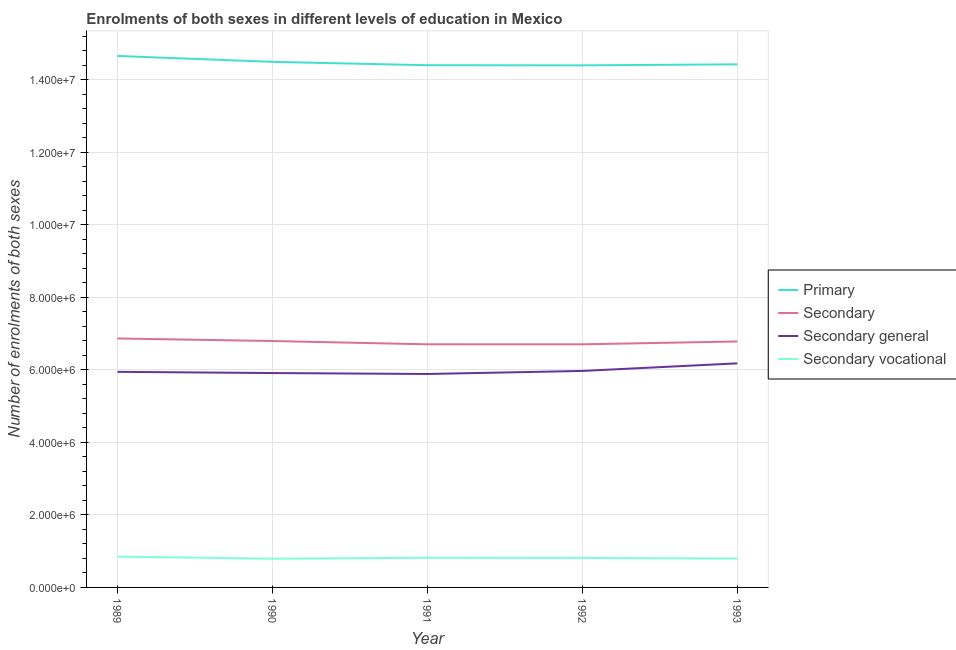How many different coloured lines are there?
Provide a succinct answer. 4. Does the line corresponding to number of enrolments in secondary vocational education intersect with the line corresponding to number of enrolments in secondary general education?
Provide a succinct answer. No. Is the number of lines equal to the number of legend labels?
Your answer should be compact. Yes. What is the number of enrolments in secondary vocational education in 1992?
Provide a short and direct response. 8.13e+05. Across all years, what is the maximum number of enrolments in primary education?
Provide a short and direct response. 1.47e+07. Across all years, what is the minimum number of enrolments in primary education?
Your response must be concise. 1.44e+07. In which year was the number of enrolments in secondary general education maximum?
Keep it short and to the point. 1993. In which year was the number of enrolments in primary education minimum?
Your answer should be very brief. 1992. What is the total number of enrolments in secondary education in the graph?
Your answer should be compact. 3.39e+07. What is the difference between the number of enrolments in secondary general education in 1990 and that in 1991?
Ensure brevity in your answer.  2.58e+04. What is the difference between the number of enrolments in secondary education in 1989 and the number of enrolments in secondary vocational education in 1991?
Ensure brevity in your answer.  6.05e+06. What is the average number of enrolments in primary education per year?
Your response must be concise. 1.45e+07. In the year 1993, what is the difference between the number of enrolments in secondary education and number of enrolments in secondary general education?
Provide a short and direct response. 6.03e+05. In how many years, is the number of enrolments in secondary general education greater than 4800000?
Provide a succinct answer. 5. What is the ratio of the number of enrolments in primary education in 1989 to that in 1992?
Give a very brief answer. 1.02. Is the number of enrolments in secondary education in 1989 less than that in 1990?
Your answer should be very brief. No. What is the difference between the highest and the second highest number of enrolments in secondary general education?
Offer a terse response. 2.09e+05. What is the difference between the highest and the lowest number of enrolments in secondary education?
Make the answer very short. 1.62e+05. Is the sum of the number of enrolments in secondary education in 1990 and 1993 greater than the maximum number of enrolments in secondary vocational education across all years?
Your response must be concise. Yes. Is it the case that in every year, the sum of the number of enrolments in primary education and number of enrolments in secondary education is greater than the number of enrolments in secondary general education?
Ensure brevity in your answer.  Yes. Is the number of enrolments in secondary education strictly less than the number of enrolments in secondary general education over the years?
Offer a very short reply. No. How many lines are there?
Your answer should be compact. 4. Does the graph contain grids?
Your answer should be very brief. Yes. What is the title of the graph?
Offer a very short reply. Enrolments of both sexes in different levels of education in Mexico. What is the label or title of the X-axis?
Ensure brevity in your answer.  Year. What is the label or title of the Y-axis?
Keep it short and to the point. Number of enrolments of both sexes. What is the Number of enrolments of both sexes of Primary in 1989?
Offer a very short reply. 1.47e+07. What is the Number of enrolments of both sexes of Secondary in 1989?
Ensure brevity in your answer.  6.87e+06. What is the Number of enrolments of both sexes in Secondary general in 1989?
Make the answer very short. 5.95e+06. What is the Number of enrolments of both sexes in Secondary vocational in 1989?
Your answer should be very brief. 8.50e+05. What is the Number of enrolments of both sexes of Primary in 1990?
Provide a short and direct response. 1.45e+07. What is the Number of enrolments of both sexes in Secondary in 1990?
Your answer should be compact. 6.80e+06. What is the Number of enrolments of both sexes in Secondary general in 1990?
Ensure brevity in your answer.  5.91e+06. What is the Number of enrolments of both sexes of Secondary vocational in 1990?
Keep it short and to the point. 7.92e+05. What is the Number of enrolments of both sexes in Primary in 1991?
Make the answer very short. 1.44e+07. What is the Number of enrolments of both sexes of Secondary in 1991?
Make the answer very short. 6.70e+06. What is the Number of enrolments of both sexes of Secondary general in 1991?
Your response must be concise. 5.89e+06. What is the Number of enrolments of both sexes in Secondary vocational in 1991?
Offer a terse response. 8.18e+05. What is the Number of enrolments of both sexes of Primary in 1992?
Ensure brevity in your answer.  1.44e+07. What is the Number of enrolments of both sexes in Secondary in 1992?
Offer a terse response. 6.70e+06. What is the Number of enrolments of both sexes in Secondary general in 1992?
Keep it short and to the point. 5.97e+06. What is the Number of enrolments of both sexes in Secondary vocational in 1992?
Provide a succinct answer. 8.13e+05. What is the Number of enrolments of both sexes in Primary in 1993?
Make the answer very short. 1.44e+07. What is the Number of enrolments of both sexes of Secondary in 1993?
Make the answer very short. 6.78e+06. What is the Number of enrolments of both sexes of Secondary general in 1993?
Offer a very short reply. 6.18e+06. What is the Number of enrolments of both sexes of Secondary vocational in 1993?
Your answer should be very brief. 7.98e+05. Across all years, what is the maximum Number of enrolments of both sexes in Primary?
Keep it short and to the point. 1.47e+07. Across all years, what is the maximum Number of enrolments of both sexes of Secondary?
Keep it short and to the point. 6.87e+06. Across all years, what is the maximum Number of enrolments of both sexes of Secondary general?
Make the answer very short. 6.18e+06. Across all years, what is the maximum Number of enrolments of both sexes of Secondary vocational?
Offer a terse response. 8.50e+05. Across all years, what is the minimum Number of enrolments of both sexes in Primary?
Provide a succinct answer. 1.44e+07. Across all years, what is the minimum Number of enrolments of both sexes of Secondary?
Your answer should be compact. 6.70e+06. Across all years, what is the minimum Number of enrolments of both sexes of Secondary general?
Provide a succinct answer. 5.89e+06. Across all years, what is the minimum Number of enrolments of both sexes in Secondary vocational?
Make the answer very short. 7.92e+05. What is the total Number of enrolments of both sexes of Primary in the graph?
Offer a very short reply. 7.24e+07. What is the total Number of enrolments of both sexes in Secondary in the graph?
Offer a terse response. 3.39e+07. What is the total Number of enrolments of both sexes in Secondary general in the graph?
Ensure brevity in your answer.  2.99e+07. What is the total Number of enrolments of both sexes of Secondary vocational in the graph?
Keep it short and to the point. 4.07e+06. What is the difference between the Number of enrolments of both sexes in Primary in 1989 and that in 1990?
Offer a very short reply. 1.63e+05. What is the difference between the Number of enrolments of both sexes in Secondary in 1989 and that in 1990?
Your response must be concise. 7.05e+04. What is the difference between the Number of enrolments of both sexes of Secondary general in 1989 and that in 1990?
Ensure brevity in your answer.  3.38e+04. What is the difference between the Number of enrolments of both sexes in Secondary vocational in 1989 and that in 1990?
Your answer should be compact. 5.72e+04. What is the difference between the Number of enrolments of both sexes of Primary in 1989 and that in 1991?
Provide a short and direct response. 2.55e+05. What is the difference between the Number of enrolments of both sexes in Secondary in 1989 and that in 1991?
Ensure brevity in your answer.  1.61e+05. What is the difference between the Number of enrolments of both sexes in Secondary general in 1989 and that in 1991?
Make the answer very short. 5.96e+04. What is the difference between the Number of enrolments of both sexes in Secondary vocational in 1989 and that in 1991?
Provide a short and direct response. 3.14e+04. What is the difference between the Number of enrolments of both sexes in Primary in 1989 and that in 1992?
Offer a very short reply. 2.59e+05. What is the difference between the Number of enrolments of both sexes of Secondary in 1989 and that in 1992?
Keep it short and to the point. 1.62e+05. What is the difference between the Number of enrolments of both sexes in Secondary general in 1989 and that in 1992?
Provide a succinct answer. -2.45e+04. What is the difference between the Number of enrolments of both sexes of Secondary vocational in 1989 and that in 1992?
Keep it short and to the point. 3.69e+04. What is the difference between the Number of enrolments of both sexes of Primary in 1989 and that in 1993?
Make the answer very short. 2.31e+05. What is the difference between the Number of enrolments of both sexes of Secondary in 1989 and that in 1993?
Make the answer very short. 8.29e+04. What is the difference between the Number of enrolments of both sexes in Secondary general in 1989 and that in 1993?
Offer a terse response. -2.34e+05. What is the difference between the Number of enrolments of both sexes in Secondary vocational in 1989 and that in 1993?
Offer a very short reply. 5.21e+04. What is the difference between the Number of enrolments of both sexes in Primary in 1990 and that in 1991?
Your answer should be very brief. 9.22e+04. What is the difference between the Number of enrolments of both sexes in Secondary in 1990 and that in 1991?
Your answer should be compact. 9.09e+04. What is the difference between the Number of enrolments of both sexes of Secondary general in 1990 and that in 1991?
Ensure brevity in your answer.  2.58e+04. What is the difference between the Number of enrolments of both sexes in Secondary vocational in 1990 and that in 1991?
Provide a succinct answer. -2.57e+04. What is the difference between the Number of enrolments of both sexes in Primary in 1990 and that in 1992?
Your answer should be very brief. 9.68e+04. What is the difference between the Number of enrolments of both sexes of Secondary in 1990 and that in 1992?
Offer a very short reply. 9.11e+04. What is the difference between the Number of enrolments of both sexes in Secondary general in 1990 and that in 1992?
Your response must be concise. -5.83e+04. What is the difference between the Number of enrolments of both sexes of Secondary vocational in 1990 and that in 1992?
Provide a short and direct response. -2.03e+04. What is the difference between the Number of enrolments of both sexes of Primary in 1990 and that in 1993?
Provide a succinct answer. 6.81e+04. What is the difference between the Number of enrolments of both sexes of Secondary in 1990 and that in 1993?
Your answer should be compact. 1.24e+04. What is the difference between the Number of enrolments of both sexes of Secondary general in 1990 and that in 1993?
Provide a short and direct response. -2.68e+05. What is the difference between the Number of enrolments of both sexes in Secondary vocational in 1990 and that in 1993?
Make the answer very short. -5026. What is the difference between the Number of enrolments of both sexes of Primary in 1991 and that in 1992?
Give a very brief answer. 4595. What is the difference between the Number of enrolments of both sexes in Secondary in 1991 and that in 1992?
Offer a very short reply. 109. What is the difference between the Number of enrolments of both sexes of Secondary general in 1991 and that in 1992?
Ensure brevity in your answer.  -8.41e+04. What is the difference between the Number of enrolments of both sexes in Secondary vocational in 1991 and that in 1992?
Keep it short and to the point. 5434. What is the difference between the Number of enrolments of both sexes in Primary in 1991 and that in 1993?
Provide a succinct answer. -2.41e+04. What is the difference between the Number of enrolments of both sexes of Secondary in 1991 and that in 1993?
Keep it short and to the point. -7.86e+04. What is the difference between the Number of enrolments of both sexes in Secondary general in 1991 and that in 1993?
Make the answer very short. -2.94e+05. What is the difference between the Number of enrolments of both sexes in Secondary vocational in 1991 and that in 1993?
Your response must be concise. 2.07e+04. What is the difference between the Number of enrolments of both sexes of Primary in 1992 and that in 1993?
Provide a short and direct response. -2.87e+04. What is the difference between the Number of enrolments of both sexes in Secondary in 1992 and that in 1993?
Keep it short and to the point. -7.87e+04. What is the difference between the Number of enrolments of both sexes of Secondary general in 1992 and that in 1993?
Offer a very short reply. -2.09e+05. What is the difference between the Number of enrolments of both sexes in Secondary vocational in 1992 and that in 1993?
Provide a succinct answer. 1.53e+04. What is the difference between the Number of enrolments of both sexes in Primary in 1989 and the Number of enrolments of both sexes in Secondary in 1990?
Give a very brief answer. 7.86e+06. What is the difference between the Number of enrolments of both sexes of Primary in 1989 and the Number of enrolments of both sexes of Secondary general in 1990?
Ensure brevity in your answer.  8.74e+06. What is the difference between the Number of enrolments of both sexes in Primary in 1989 and the Number of enrolments of both sexes in Secondary vocational in 1990?
Your answer should be compact. 1.39e+07. What is the difference between the Number of enrolments of both sexes of Secondary in 1989 and the Number of enrolments of both sexes of Secondary general in 1990?
Provide a succinct answer. 9.54e+05. What is the difference between the Number of enrolments of both sexes in Secondary in 1989 and the Number of enrolments of both sexes in Secondary vocational in 1990?
Keep it short and to the point. 6.07e+06. What is the difference between the Number of enrolments of both sexes of Secondary general in 1989 and the Number of enrolments of both sexes of Secondary vocational in 1990?
Offer a terse response. 5.15e+06. What is the difference between the Number of enrolments of both sexes in Primary in 1989 and the Number of enrolments of both sexes in Secondary in 1991?
Provide a short and direct response. 7.95e+06. What is the difference between the Number of enrolments of both sexes of Primary in 1989 and the Number of enrolments of both sexes of Secondary general in 1991?
Keep it short and to the point. 8.77e+06. What is the difference between the Number of enrolments of both sexes of Primary in 1989 and the Number of enrolments of both sexes of Secondary vocational in 1991?
Your answer should be compact. 1.38e+07. What is the difference between the Number of enrolments of both sexes of Secondary in 1989 and the Number of enrolments of both sexes of Secondary general in 1991?
Your response must be concise. 9.80e+05. What is the difference between the Number of enrolments of both sexes in Secondary in 1989 and the Number of enrolments of both sexes in Secondary vocational in 1991?
Provide a short and direct response. 6.05e+06. What is the difference between the Number of enrolments of both sexes of Secondary general in 1989 and the Number of enrolments of both sexes of Secondary vocational in 1991?
Your answer should be compact. 5.13e+06. What is the difference between the Number of enrolments of both sexes of Primary in 1989 and the Number of enrolments of both sexes of Secondary in 1992?
Ensure brevity in your answer.  7.95e+06. What is the difference between the Number of enrolments of both sexes of Primary in 1989 and the Number of enrolments of both sexes of Secondary general in 1992?
Keep it short and to the point. 8.69e+06. What is the difference between the Number of enrolments of both sexes of Primary in 1989 and the Number of enrolments of both sexes of Secondary vocational in 1992?
Provide a succinct answer. 1.38e+07. What is the difference between the Number of enrolments of both sexes in Secondary in 1989 and the Number of enrolments of both sexes in Secondary general in 1992?
Keep it short and to the point. 8.96e+05. What is the difference between the Number of enrolments of both sexes of Secondary in 1989 and the Number of enrolments of both sexes of Secondary vocational in 1992?
Provide a succinct answer. 6.05e+06. What is the difference between the Number of enrolments of both sexes of Secondary general in 1989 and the Number of enrolments of both sexes of Secondary vocational in 1992?
Give a very brief answer. 5.13e+06. What is the difference between the Number of enrolments of both sexes of Primary in 1989 and the Number of enrolments of both sexes of Secondary in 1993?
Give a very brief answer. 7.87e+06. What is the difference between the Number of enrolments of both sexes of Primary in 1989 and the Number of enrolments of both sexes of Secondary general in 1993?
Make the answer very short. 8.48e+06. What is the difference between the Number of enrolments of both sexes in Primary in 1989 and the Number of enrolments of both sexes in Secondary vocational in 1993?
Offer a terse response. 1.39e+07. What is the difference between the Number of enrolments of both sexes of Secondary in 1989 and the Number of enrolments of both sexes of Secondary general in 1993?
Provide a short and direct response. 6.86e+05. What is the difference between the Number of enrolments of both sexes of Secondary in 1989 and the Number of enrolments of both sexes of Secondary vocational in 1993?
Provide a succinct answer. 6.07e+06. What is the difference between the Number of enrolments of both sexes of Secondary general in 1989 and the Number of enrolments of both sexes of Secondary vocational in 1993?
Provide a succinct answer. 5.15e+06. What is the difference between the Number of enrolments of both sexes of Primary in 1990 and the Number of enrolments of both sexes of Secondary in 1991?
Your response must be concise. 7.79e+06. What is the difference between the Number of enrolments of both sexes of Primary in 1990 and the Number of enrolments of both sexes of Secondary general in 1991?
Give a very brief answer. 8.61e+06. What is the difference between the Number of enrolments of both sexes of Primary in 1990 and the Number of enrolments of both sexes of Secondary vocational in 1991?
Make the answer very short. 1.37e+07. What is the difference between the Number of enrolments of both sexes of Secondary in 1990 and the Number of enrolments of both sexes of Secondary general in 1991?
Give a very brief answer. 9.09e+05. What is the difference between the Number of enrolments of both sexes of Secondary in 1990 and the Number of enrolments of both sexes of Secondary vocational in 1991?
Provide a succinct answer. 5.98e+06. What is the difference between the Number of enrolments of both sexes of Secondary general in 1990 and the Number of enrolments of both sexes of Secondary vocational in 1991?
Provide a short and direct response. 5.09e+06. What is the difference between the Number of enrolments of both sexes in Primary in 1990 and the Number of enrolments of both sexes in Secondary in 1992?
Your answer should be very brief. 7.79e+06. What is the difference between the Number of enrolments of both sexes in Primary in 1990 and the Number of enrolments of both sexes in Secondary general in 1992?
Provide a short and direct response. 8.52e+06. What is the difference between the Number of enrolments of both sexes of Primary in 1990 and the Number of enrolments of both sexes of Secondary vocational in 1992?
Offer a terse response. 1.37e+07. What is the difference between the Number of enrolments of both sexes in Secondary in 1990 and the Number of enrolments of both sexes in Secondary general in 1992?
Offer a terse response. 8.25e+05. What is the difference between the Number of enrolments of both sexes in Secondary in 1990 and the Number of enrolments of both sexes in Secondary vocational in 1992?
Provide a short and direct response. 5.98e+06. What is the difference between the Number of enrolments of both sexes in Secondary general in 1990 and the Number of enrolments of both sexes in Secondary vocational in 1992?
Ensure brevity in your answer.  5.10e+06. What is the difference between the Number of enrolments of both sexes of Primary in 1990 and the Number of enrolments of both sexes of Secondary in 1993?
Give a very brief answer. 7.71e+06. What is the difference between the Number of enrolments of both sexes in Primary in 1990 and the Number of enrolments of both sexes in Secondary general in 1993?
Offer a terse response. 8.31e+06. What is the difference between the Number of enrolments of both sexes in Primary in 1990 and the Number of enrolments of both sexes in Secondary vocational in 1993?
Ensure brevity in your answer.  1.37e+07. What is the difference between the Number of enrolments of both sexes of Secondary in 1990 and the Number of enrolments of both sexes of Secondary general in 1993?
Give a very brief answer. 6.16e+05. What is the difference between the Number of enrolments of both sexes in Secondary in 1990 and the Number of enrolments of both sexes in Secondary vocational in 1993?
Your response must be concise. 6.00e+06. What is the difference between the Number of enrolments of both sexes of Secondary general in 1990 and the Number of enrolments of both sexes of Secondary vocational in 1993?
Provide a succinct answer. 5.11e+06. What is the difference between the Number of enrolments of both sexes in Primary in 1991 and the Number of enrolments of both sexes in Secondary in 1992?
Offer a terse response. 7.70e+06. What is the difference between the Number of enrolments of both sexes in Primary in 1991 and the Number of enrolments of both sexes in Secondary general in 1992?
Provide a short and direct response. 8.43e+06. What is the difference between the Number of enrolments of both sexes of Primary in 1991 and the Number of enrolments of both sexes of Secondary vocational in 1992?
Offer a very short reply. 1.36e+07. What is the difference between the Number of enrolments of both sexes of Secondary in 1991 and the Number of enrolments of both sexes of Secondary general in 1992?
Provide a succinct answer. 7.34e+05. What is the difference between the Number of enrolments of both sexes of Secondary in 1991 and the Number of enrolments of both sexes of Secondary vocational in 1992?
Your answer should be compact. 5.89e+06. What is the difference between the Number of enrolments of both sexes of Secondary general in 1991 and the Number of enrolments of both sexes of Secondary vocational in 1992?
Keep it short and to the point. 5.07e+06. What is the difference between the Number of enrolments of both sexes of Primary in 1991 and the Number of enrolments of both sexes of Secondary in 1993?
Your answer should be compact. 7.62e+06. What is the difference between the Number of enrolments of both sexes of Primary in 1991 and the Number of enrolments of both sexes of Secondary general in 1993?
Your response must be concise. 8.22e+06. What is the difference between the Number of enrolments of both sexes of Primary in 1991 and the Number of enrolments of both sexes of Secondary vocational in 1993?
Offer a very short reply. 1.36e+07. What is the difference between the Number of enrolments of both sexes in Secondary in 1991 and the Number of enrolments of both sexes in Secondary general in 1993?
Ensure brevity in your answer.  5.25e+05. What is the difference between the Number of enrolments of both sexes of Secondary in 1991 and the Number of enrolments of both sexes of Secondary vocational in 1993?
Ensure brevity in your answer.  5.91e+06. What is the difference between the Number of enrolments of both sexes of Secondary general in 1991 and the Number of enrolments of both sexes of Secondary vocational in 1993?
Your response must be concise. 5.09e+06. What is the difference between the Number of enrolments of both sexes of Primary in 1992 and the Number of enrolments of both sexes of Secondary in 1993?
Give a very brief answer. 7.61e+06. What is the difference between the Number of enrolments of both sexes of Primary in 1992 and the Number of enrolments of both sexes of Secondary general in 1993?
Your answer should be compact. 8.22e+06. What is the difference between the Number of enrolments of both sexes in Primary in 1992 and the Number of enrolments of both sexes in Secondary vocational in 1993?
Offer a terse response. 1.36e+07. What is the difference between the Number of enrolments of both sexes of Secondary in 1992 and the Number of enrolments of both sexes of Secondary general in 1993?
Give a very brief answer. 5.25e+05. What is the difference between the Number of enrolments of both sexes of Secondary in 1992 and the Number of enrolments of both sexes of Secondary vocational in 1993?
Your answer should be compact. 5.91e+06. What is the difference between the Number of enrolments of both sexes in Secondary general in 1992 and the Number of enrolments of both sexes in Secondary vocational in 1993?
Provide a succinct answer. 5.17e+06. What is the average Number of enrolments of both sexes of Primary per year?
Your answer should be very brief. 1.45e+07. What is the average Number of enrolments of both sexes of Secondary per year?
Your answer should be compact. 6.77e+06. What is the average Number of enrolments of both sexes in Secondary general per year?
Keep it short and to the point. 5.98e+06. What is the average Number of enrolments of both sexes in Secondary vocational per year?
Offer a very short reply. 8.14e+05. In the year 1989, what is the difference between the Number of enrolments of both sexes of Primary and Number of enrolments of both sexes of Secondary?
Ensure brevity in your answer.  7.79e+06. In the year 1989, what is the difference between the Number of enrolments of both sexes of Primary and Number of enrolments of both sexes of Secondary general?
Your answer should be compact. 8.71e+06. In the year 1989, what is the difference between the Number of enrolments of both sexes of Primary and Number of enrolments of both sexes of Secondary vocational?
Your response must be concise. 1.38e+07. In the year 1989, what is the difference between the Number of enrolments of both sexes of Secondary and Number of enrolments of both sexes of Secondary general?
Keep it short and to the point. 9.20e+05. In the year 1989, what is the difference between the Number of enrolments of both sexes in Secondary and Number of enrolments of both sexes in Secondary vocational?
Offer a terse response. 6.02e+06. In the year 1989, what is the difference between the Number of enrolments of both sexes of Secondary general and Number of enrolments of both sexes of Secondary vocational?
Offer a terse response. 5.10e+06. In the year 1990, what is the difference between the Number of enrolments of both sexes in Primary and Number of enrolments of both sexes in Secondary?
Your answer should be very brief. 7.70e+06. In the year 1990, what is the difference between the Number of enrolments of both sexes in Primary and Number of enrolments of both sexes in Secondary general?
Make the answer very short. 8.58e+06. In the year 1990, what is the difference between the Number of enrolments of both sexes of Primary and Number of enrolments of both sexes of Secondary vocational?
Your response must be concise. 1.37e+07. In the year 1990, what is the difference between the Number of enrolments of both sexes in Secondary and Number of enrolments of both sexes in Secondary general?
Offer a very short reply. 8.83e+05. In the year 1990, what is the difference between the Number of enrolments of both sexes of Secondary and Number of enrolments of both sexes of Secondary vocational?
Keep it short and to the point. 6.00e+06. In the year 1990, what is the difference between the Number of enrolments of both sexes in Secondary general and Number of enrolments of both sexes in Secondary vocational?
Your answer should be compact. 5.12e+06. In the year 1991, what is the difference between the Number of enrolments of both sexes in Primary and Number of enrolments of both sexes in Secondary?
Your answer should be very brief. 7.70e+06. In the year 1991, what is the difference between the Number of enrolments of both sexes in Primary and Number of enrolments of both sexes in Secondary general?
Your answer should be compact. 8.52e+06. In the year 1991, what is the difference between the Number of enrolments of both sexes in Primary and Number of enrolments of both sexes in Secondary vocational?
Provide a short and direct response. 1.36e+07. In the year 1991, what is the difference between the Number of enrolments of both sexes of Secondary and Number of enrolments of both sexes of Secondary general?
Offer a terse response. 8.18e+05. In the year 1991, what is the difference between the Number of enrolments of both sexes of Secondary and Number of enrolments of both sexes of Secondary vocational?
Give a very brief answer. 5.89e+06. In the year 1991, what is the difference between the Number of enrolments of both sexes of Secondary general and Number of enrolments of both sexes of Secondary vocational?
Make the answer very short. 5.07e+06. In the year 1992, what is the difference between the Number of enrolments of both sexes of Primary and Number of enrolments of both sexes of Secondary?
Provide a succinct answer. 7.69e+06. In the year 1992, what is the difference between the Number of enrolments of both sexes of Primary and Number of enrolments of both sexes of Secondary general?
Provide a short and direct response. 8.43e+06. In the year 1992, what is the difference between the Number of enrolments of both sexes in Primary and Number of enrolments of both sexes in Secondary vocational?
Your answer should be compact. 1.36e+07. In the year 1992, what is the difference between the Number of enrolments of both sexes of Secondary and Number of enrolments of both sexes of Secondary general?
Your response must be concise. 7.34e+05. In the year 1992, what is the difference between the Number of enrolments of both sexes of Secondary and Number of enrolments of both sexes of Secondary vocational?
Keep it short and to the point. 5.89e+06. In the year 1992, what is the difference between the Number of enrolments of both sexes of Secondary general and Number of enrolments of both sexes of Secondary vocational?
Give a very brief answer. 5.16e+06. In the year 1993, what is the difference between the Number of enrolments of both sexes in Primary and Number of enrolments of both sexes in Secondary?
Keep it short and to the point. 7.64e+06. In the year 1993, what is the difference between the Number of enrolments of both sexes in Primary and Number of enrolments of both sexes in Secondary general?
Offer a terse response. 8.25e+06. In the year 1993, what is the difference between the Number of enrolments of both sexes in Primary and Number of enrolments of both sexes in Secondary vocational?
Provide a short and direct response. 1.36e+07. In the year 1993, what is the difference between the Number of enrolments of both sexes of Secondary and Number of enrolments of both sexes of Secondary general?
Provide a short and direct response. 6.03e+05. In the year 1993, what is the difference between the Number of enrolments of both sexes of Secondary and Number of enrolments of both sexes of Secondary vocational?
Offer a terse response. 5.99e+06. In the year 1993, what is the difference between the Number of enrolments of both sexes in Secondary general and Number of enrolments of both sexes in Secondary vocational?
Make the answer very short. 5.38e+06. What is the ratio of the Number of enrolments of both sexes in Primary in 1989 to that in 1990?
Give a very brief answer. 1.01. What is the ratio of the Number of enrolments of both sexes in Secondary in 1989 to that in 1990?
Provide a short and direct response. 1.01. What is the ratio of the Number of enrolments of both sexes in Secondary vocational in 1989 to that in 1990?
Provide a succinct answer. 1.07. What is the ratio of the Number of enrolments of both sexes of Primary in 1989 to that in 1991?
Offer a very short reply. 1.02. What is the ratio of the Number of enrolments of both sexes in Secondary in 1989 to that in 1991?
Give a very brief answer. 1.02. What is the ratio of the Number of enrolments of both sexes of Secondary vocational in 1989 to that in 1991?
Give a very brief answer. 1.04. What is the ratio of the Number of enrolments of both sexes in Secondary in 1989 to that in 1992?
Offer a very short reply. 1.02. What is the ratio of the Number of enrolments of both sexes in Secondary general in 1989 to that in 1992?
Give a very brief answer. 1. What is the ratio of the Number of enrolments of both sexes of Secondary vocational in 1989 to that in 1992?
Provide a succinct answer. 1.05. What is the ratio of the Number of enrolments of both sexes of Secondary in 1989 to that in 1993?
Your answer should be very brief. 1.01. What is the ratio of the Number of enrolments of both sexes of Secondary general in 1989 to that in 1993?
Ensure brevity in your answer.  0.96. What is the ratio of the Number of enrolments of both sexes in Secondary vocational in 1989 to that in 1993?
Your answer should be very brief. 1.07. What is the ratio of the Number of enrolments of both sexes of Primary in 1990 to that in 1991?
Give a very brief answer. 1.01. What is the ratio of the Number of enrolments of both sexes of Secondary in 1990 to that in 1991?
Provide a succinct answer. 1.01. What is the ratio of the Number of enrolments of both sexes in Secondary general in 1990 to that in 1991?
Your answer should be very brief. 1. What is the ratio of the Number of enrolments of both sexes of Secondary vocational in 1990 to that in 1991?
Ensure brevity in your answer.  0.97. What is the ratio of the Number of enrolments of both sexes in Secondary in 1990 to that in 1992?
Provide a succinct answer. 1.01. What is the ratio of the Number of enrolments of both sexes in Secondary general in 1990 to that in 1992?
Your answer should be very brief. 0.99. What is the ratio of the Number of enrolments of both sexes of Secondary vocational in 1990 to that in 1992?
Offer a terse response. 0.97. What is the ratio of the Number of enrolments of both sexes of Secondary in 1990 to that in 1993?
Your answer should be very brief. 1. What is the ratio of the Number of enrolments of both sexes in Secondary general in 1990 to that in 1993?
Your response must be concise. 0.96. What is the ratio of the Number of enrolments of both sexes in Secondary vocational in 1990 to that in 1993?
Your response must be concise. 0.99. What is the ratio of the Number of enrolments of both sexes in Primary in 1991 to that in 1992?
Offer a terse response. 1. What is the ratio of the Number of enrolments of both sexes of Secondary general in 1991 to that in 1992?
Ensure brevity in your answer.  0.99. What is the ratio of the Number of enrolments of both sexes of Secondary vocational in 1991 to that in 1992?
Your response must be concise. 1.01. What is the ratio of the Number of enrolments of both sexes in Secondary in 1991 to that in 1993?
Provide a short and direct response. 0.99. What is the ratio of the Number of enrolments of both sexes of Secondary general in 1991 to that in 1993?
Ensure brevity in your answer.  0.95. What is the ratio of the Number of enrolments of both sexes of Secondary vocational in 1991 to that in 1993?
Provide a short and direct response. 1.03. What is the ratio of the Number of enrolments of both sexes in Secondary in 1992 to that in 1993?
Your response must be concise. 0.99. What is the ratio of the Number of enrolments of both sexes in Secondary general in 1992 to that in 1993?
Provide a short and direct response. 0.97. What is the ratio of the Number of enrolments of both sexes in Secondary vocational in 1992 to that in 1993?
Your response must be concise. 1.02. What is the difference between the highest and the second highest Number of enrolments of both sexes of Primary?
Offer a very short reply. 1.63e+05. What is the difference between the highest and the second highest Number of enrolments of both sexes of Secondary?
Offer a very short reply. 7.05e+04. What is the difference between the highest and the second highest Number of enrolments of both sexes of Secondary general?
Keep it short and to the point. 2.09e+05. What is the difference between the highest and the second highest Number of enrolments of both sexes in Secondary vocational?
Keep it short and to the point. 3.14e+04. What is the difference between the highest and the lowest Number of enrolments of both sexes of Primary?
Your answer should be compact. 2.59e+05. What is the difference between the highest and the lowest Number of enrolments of both sexes in Secondary?
Keep it short and to the point. 1.62e+05. What is the difference between the highest and the lowest Number of enrolments of both sexes in Secondary general?
Ensure brevity in your answer.  2.94e+05. What is the difference between the highest and the lowest Number of enrolments of both sexes of Secondary vocational?
Your answer should be very brief. 5.72e+04. 